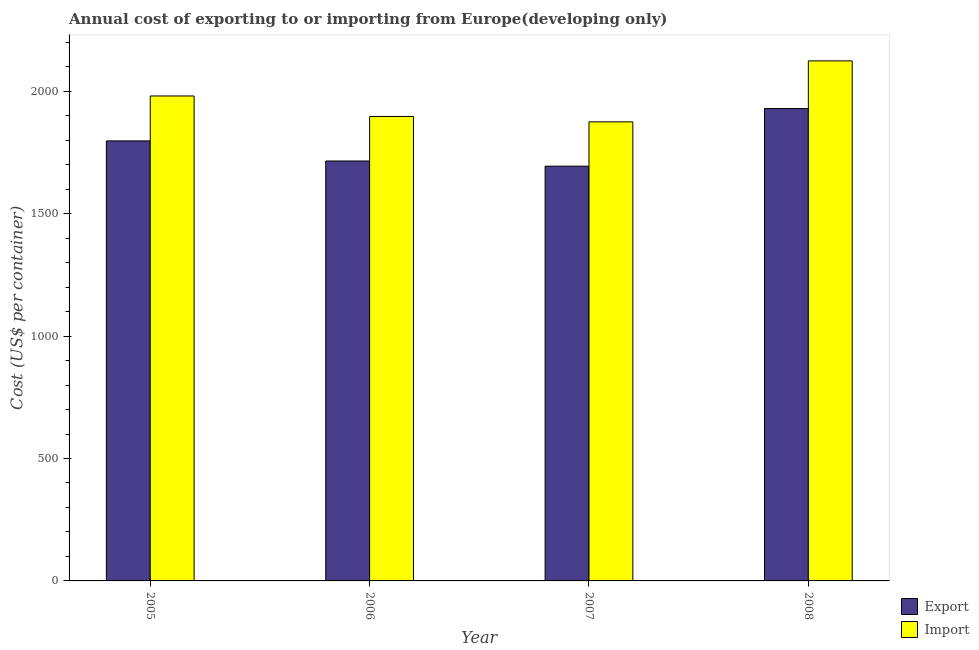How many groups of bars are there?
Make the answer very short. 4. How many bars are there on the 3rd tick from the right?
Provide a succinct answer. 2. What is the label of the 4th group of bars from the left?
Give a very brief answer. 2008. What is the export cost in 2007?
Keep it short and to the point. 1693.94. Across all years, what is the maximum import cost?
Provide a succinct answer. 2123.94. Across all years, what is the minimum import cost?
Offer a very short reply. 1874.94. In which year was the export cost minimum?
Offer a terse response. 2007. What is the total export cost in the graph?
Your answer should be compact. 7135.4. What is the difference between the export cost in 2005 and that in 2006?
Give a very brief answer. 82.06. What is the difference between the import cost in 2006 and the export cost in 2007?
Your answer should be compact. 22. What is the average import cost per year?
Provide a succinct answer. 1969.11. In how many years, is the import cost greater than 1300 US$?
Ensure brevity in your answer.  4. What is the ratio of the export cost in 2005 to that in 2008?
Your response must be concise. 0.93. Is the export cost in 2006 less than that in 2007?
Your answer should be compact. No. Is the difference between the import cost in 2005 and 2006 greater than the difference between the export cost in 2005 and 2006?
Offer a terse response. No. What is the difference between the highest and the second highest import cost?
Keep it short and to the point. 143.36. What is the difference between the highest and the lowest export cost?
Make the answer very short. 235.33. In how many years, is the export cost greater than the average export cost taken over all years?
Make the answer very short. 2. What does the 2nd bar from the left in 2008 represents?
Provide a succinct answer. Import. What does the 1st bar from the right in 2007 represents?
Keep it short and to the point. Import. How many years are there in the graph?
Give a very brief answer. 4. What is the difference between two consecutive major ticks on the Y-axis?
Keep it short and to the point. 500. Does the graph contain any zero values?
Your answer should be compact. No. Does the graph contain grids?
Your answer should be very brief. No. Where does the legend appear in the graph?
Your answer should be compact. Bottom right. How many legend labels are there?
Ensure brevity in your answer.  2. How are the legend labels stacked?
Provide a short and direct response. Vertical. What is the title of the graph?
Your answer should be compact. Annual cost of exporting to or importing from Europe(developing only). What is the label or title of the X-axis?
Provide a short and direct response. Year. What is the label or title of the Y-axis?
Your response must be concise. Cost (US$ per container). What is the Cost (US$ per container) in Export in 2005?
Provide a short and direct response. 1797.12. What is the Cost (US$ per container) in Import in 2005?
Offer a very short reply. 1980.59. What is the Cost (US$ per container) in Export in 2006?
Offer a terse response. 1715.06. What is the Cost (US$ per container) of Import in 2006?
Provide a succinct answer. 1896.94. What is the Cost (US$ per container) of Export in 2007?
Provide a succinct answer. 1693.94. What is the Cost (US$ per container) of Import in 2007?
Give a very brief answer. 1874.94. What is the Cost (US$ per container) in Export in 2008?
Ensure brevity in your answer.  1929.28. What is the Cost (US$ per container) of Import in 2008?
Your answer should be compact. 2123.94. Across all years, what is the maximum Cost (US$ per container) in Export?
Your response must be concise. 1929.28. Across all years, what is the maximum Cost (US$ per container) of Import?
Make the answer very short. 2123.94. Across all years, what is the minimum Cost (US$ per container) in Export?
Your answer should be very brief. 1693.94. Across all years, what is the minimum Cost (US$ per container) of Import?
Offer a very short reply. 1874.94. What is the total Cost (US$ per container) in Export in the graph?
Give a very brief answer. 7135.4. What is the total Cost (US$ per container) in Import in the graph?
Your answer should be very brief. 7876.42. What is the difference between the Cost (US$ per container) of Export in 2005 and that in 2006?
Your answer should be compact. 82.06. What is the difference between the Cost (US$ per container) in Import in 2005 and that in 2006?
Your answer should be very brief. 83.64. What is the difference between the Cost (US$ per container) of Export in 2005 and that in 2007?
Provide a succinct answer. 103.17. What is the difference between the Cost (US$ per container) of Import in 2005 and that in 2007?
Offer a terse response. 105.64. What is the difference between the Cost (US$ per container) in Export in 2005 and that in 2008?
Make the answer very short. -132.16. What is the difference between the Cost (US$ per container) of Import in 2005 and that in 2008?
Keep it short and to the point. -143.36. What is the difference between the Cost (US$ per container) in Export in 2006 and that in 2007?
Offer a very short reply. 21.11. What is the difference between the Cost (US$ per container) in Export in 2006 and that in 2008?
Give a very brief answer. -214.22. What is the difference between the Cost (US$ per container) of Import in 2006 and that in 2008?
Provide a succinct answer. -227. What is the difference between the Cost (US$ per container) of Export in 2007 and that in 2008?
Your answer should be compact. -235.33. What is the difference between the Cost (US$ per container) of Import in 2007 and that in 2008?
Provide a succinct answer. -249. What is the difference between the Cost (US$ per container) of Export in 2005 and the Cost (US$ per container) of Import in 2006?
Offer a very short reply. -99.83. What is the difference between the Cost (US$ per container) of Export in 2005 and the Cost (US$ per container) of Import in 2007?
Keep it short and to the point. -77.83. What is the difference between the Cost (US$ per container) of Export in 2005 and the Cost (US$ per container) of Import in 2008?
Offer a very short reply. -326.83. What is the difference between the Cost (US$ per container) of Export in 2006 and the Cost (US$ per container) of Import in 2007?
Ensure brevity in your answer.  -159.89. What is the difference between the Cost (US$ per container) in Export in 2006 and the Cost (US$ per container) in Import in 2008?
Provide a short and direct response. -408.89. What is the difference between the Cost (US$ per container) in Export in 2007 and the Cost (US$ per container) in Import in 2008?
Make the answer very short. -430. What is the average Cost (US$ per container) of Export per year?
Offer a terse response. 1783.85. What is the average Cost (US$ per container) in Import per year?
Provide a short and direct response. 1969.11. In the year 2005, what is the difference between the Cost (US$ per container) of Export and Cost (US$ per container) of Import?
Provide a succinct answer. -183.47. In the year 2006, what is the difference between the Cost (US$ per container) in Export and Cost (US$ per container) in Import?
Your response must be concise. -181.89. In the year 2007, what is the difference between the Cost (US$ per container) of Export and Cost (US$ per container) of Import?
Give a very brief answer. -181. In the year 2008, what is the difference between the Cost (US$ per container) in Export and Cost (US$ per container) in Import?
Offer a terse response. -194.67. What is the ratio of the Cost (US$ per container) in Export in 2005 to that in 2006?
Make the answer very short. 1.05. What is the ratio of the Cost (US$ per container) of Import in 2005 to that in 2006?
Your answer should be very brief. 1.04. What is the ratio of the Cost (US$ per container) of Export in 2005 to that in 2007?
Provide a succinct answer. 1.06. What is the ratio of the Cost (US$ per container) in Import in 2005 to that in 2007?
Offer a very short reply. 1.06. What is the ratio of the Cost (US$ per container) of Export in 2005 to that in 2008?
Make the answer very short. 0.93. What is the ratio of the Cost (US$ per container) of Import in 2005 to that in 2008?
Provide a succinct answer. 0.93. What is the ratio of the Cost (US$ per container) of Export in 2006 to that in 2007?
Your response must be concise. 1.01. What is the ratio of the Cost (US$ per container) in Import in 2006 to that in 2007?
Your response must be concise. 1.01. What is the ratio of the Cost (US$ per container) in Export in 2006 to that in 2008?
Make the answer very short. 0.89. What is the ratio of the Cost (US$ per container) of Import in 2006 to that in 2008?
Your response must be concise. 0.89. What is the ratio of the Cost (US$ per container) of Export in 2007 to that in 2008?
Offer a terse response. 0.88. What is the ratio of the Cost (US$ per container) of Import in 2007 to that in 2008?
Give a very brief answer. 0.88. What is the difference between the highest and the second highest Cost (US$ per container) in Export?
Your response must be concise. 132.16. What is the difference between the highest and the second highest Cost (US$ per container) of Import?
Make the answer very short. 143.36. What is the difference between the highest and the lowest Cost (US$ per container) of Export?
Offer a terse response. 235.33. What is the difference between the highest and the lowest Cost (US$ per container) in Import?
Provide a succinct answer. 249. 